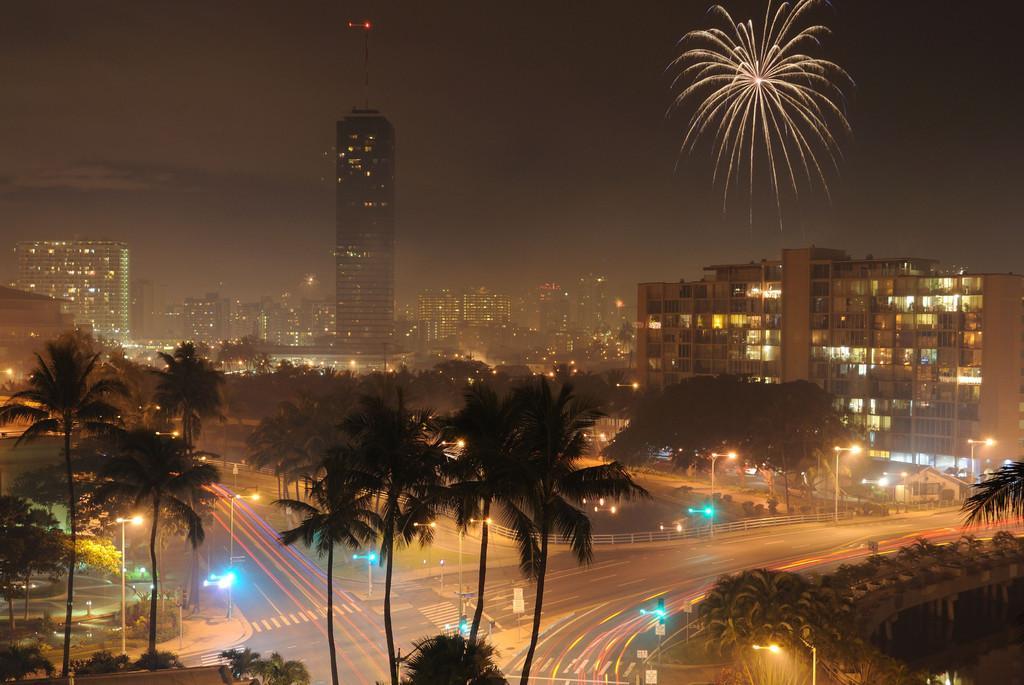Could you give a brief overview of what you see in this image? In this image we can see a group of buildings with windows and some lights. We can also see the roads, poles, street lamps, water, a group of trees and some fireworks in the sky. 